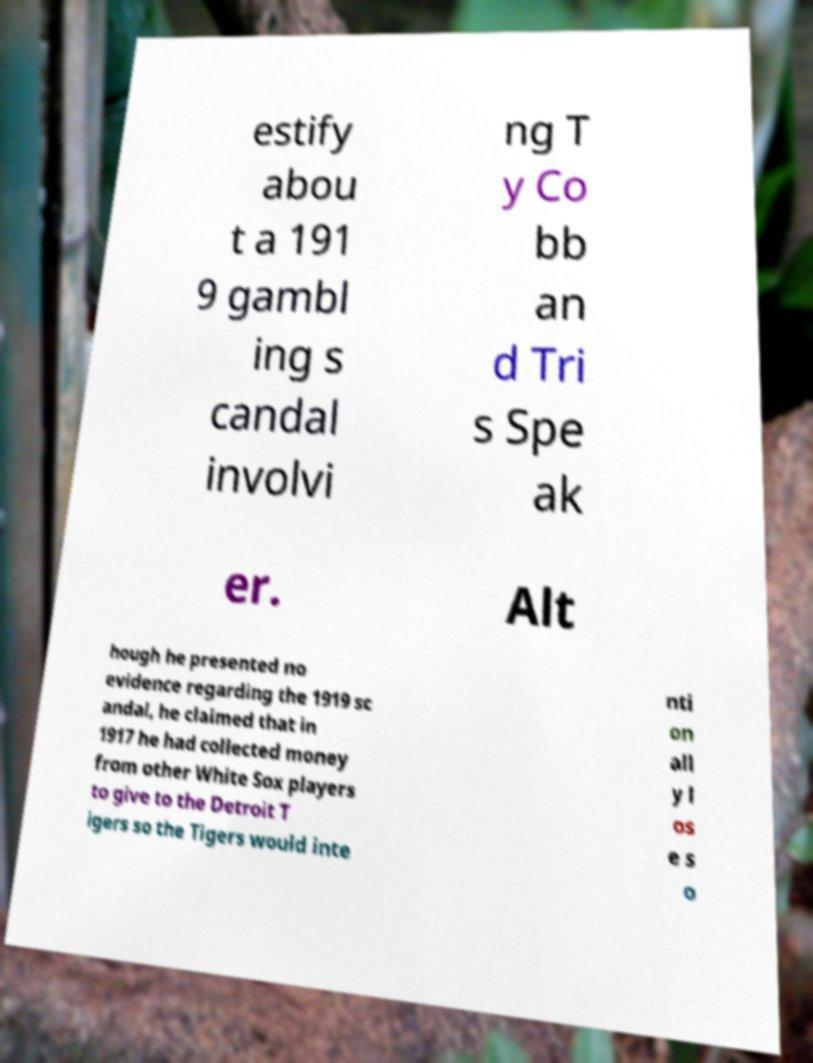What messages or text are displayed in this image? I need them in a readable, typed format. estify abou t a 191 9 gambl ing s candal involvi ng T y Co bb an d Tri s Spe ak er. Alt hough he presented no evidence regarding the 1919 sc andal, he claimed that in 1917 he had collected money from other White Sox players to give to the Detroit T igers so the Tigers would inte nti on all y l os e s o 